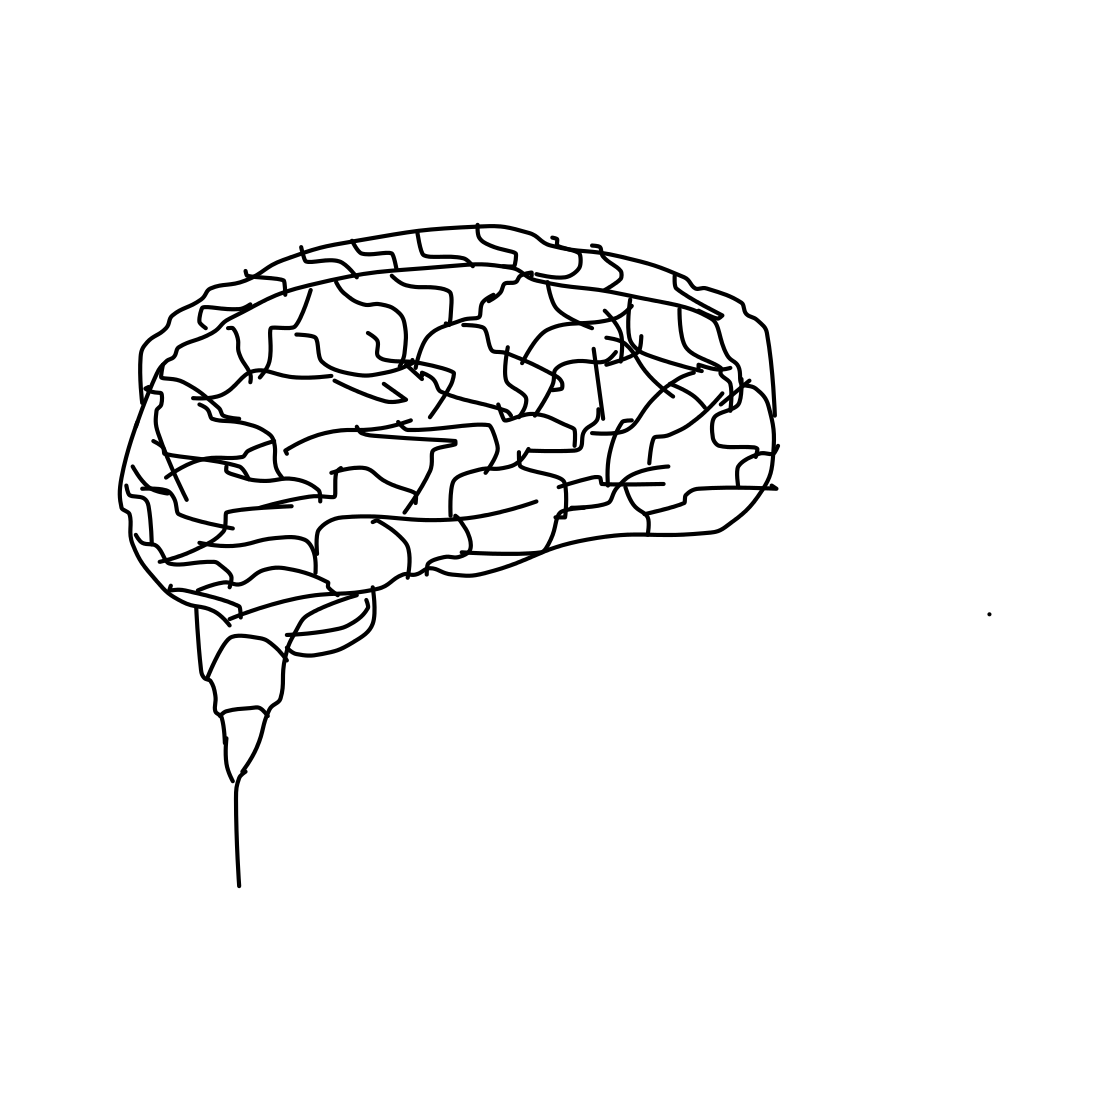What is depicted in this image? The image showcases a simplistic line drawing of the human brain, illustrating its general shape and some internal divisions that represent different brain areas. 